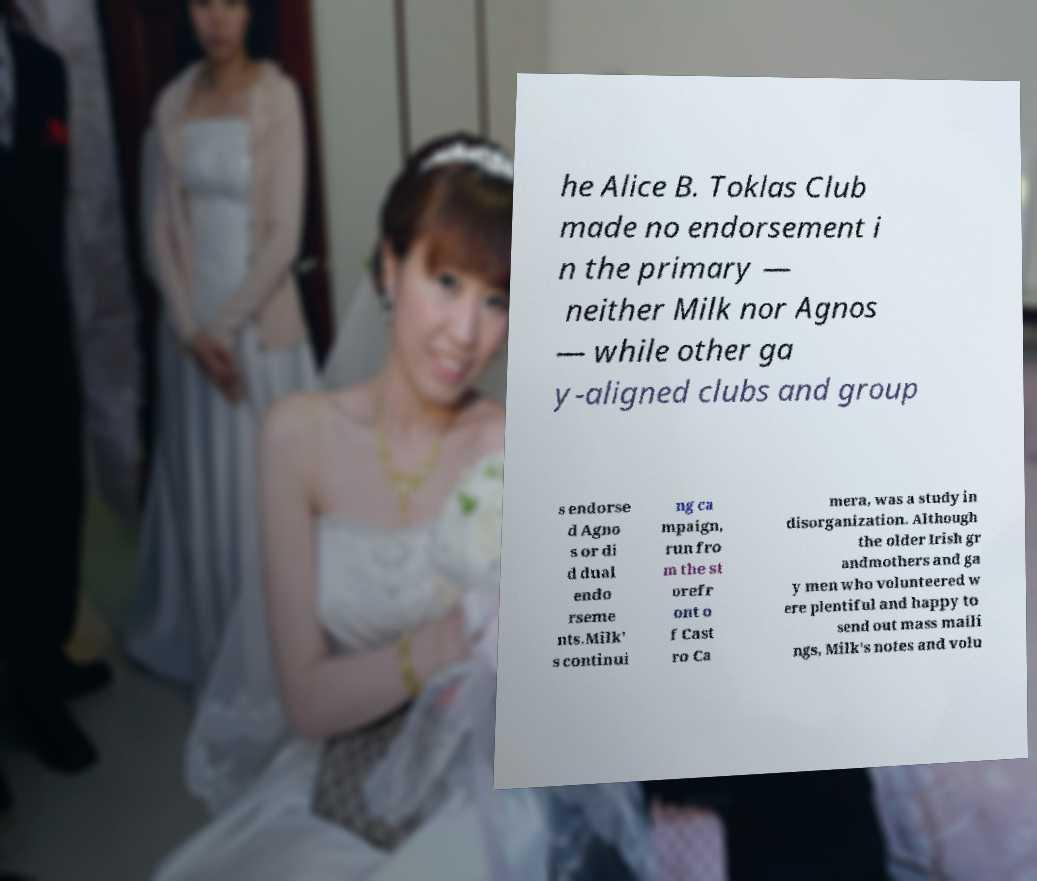I need the written content from this picture converted into text. Can you do that? he Alice B. Toklas Club made no endorsement i n the primary — neither Milk nor Agnos — while other ga y-aligned clubs and group s endorse d Agno s or di d dual endo rseme nts.Milk' s continui ng ca mpaign, run fro m the st orefr ont o f Cast ro Ca mera, was a study in disorganization. Although the older Irish gr andmothers and ga y men who volunteered w ere plentiful and happy to send out mass maili ngs, Milk's notes and volu 